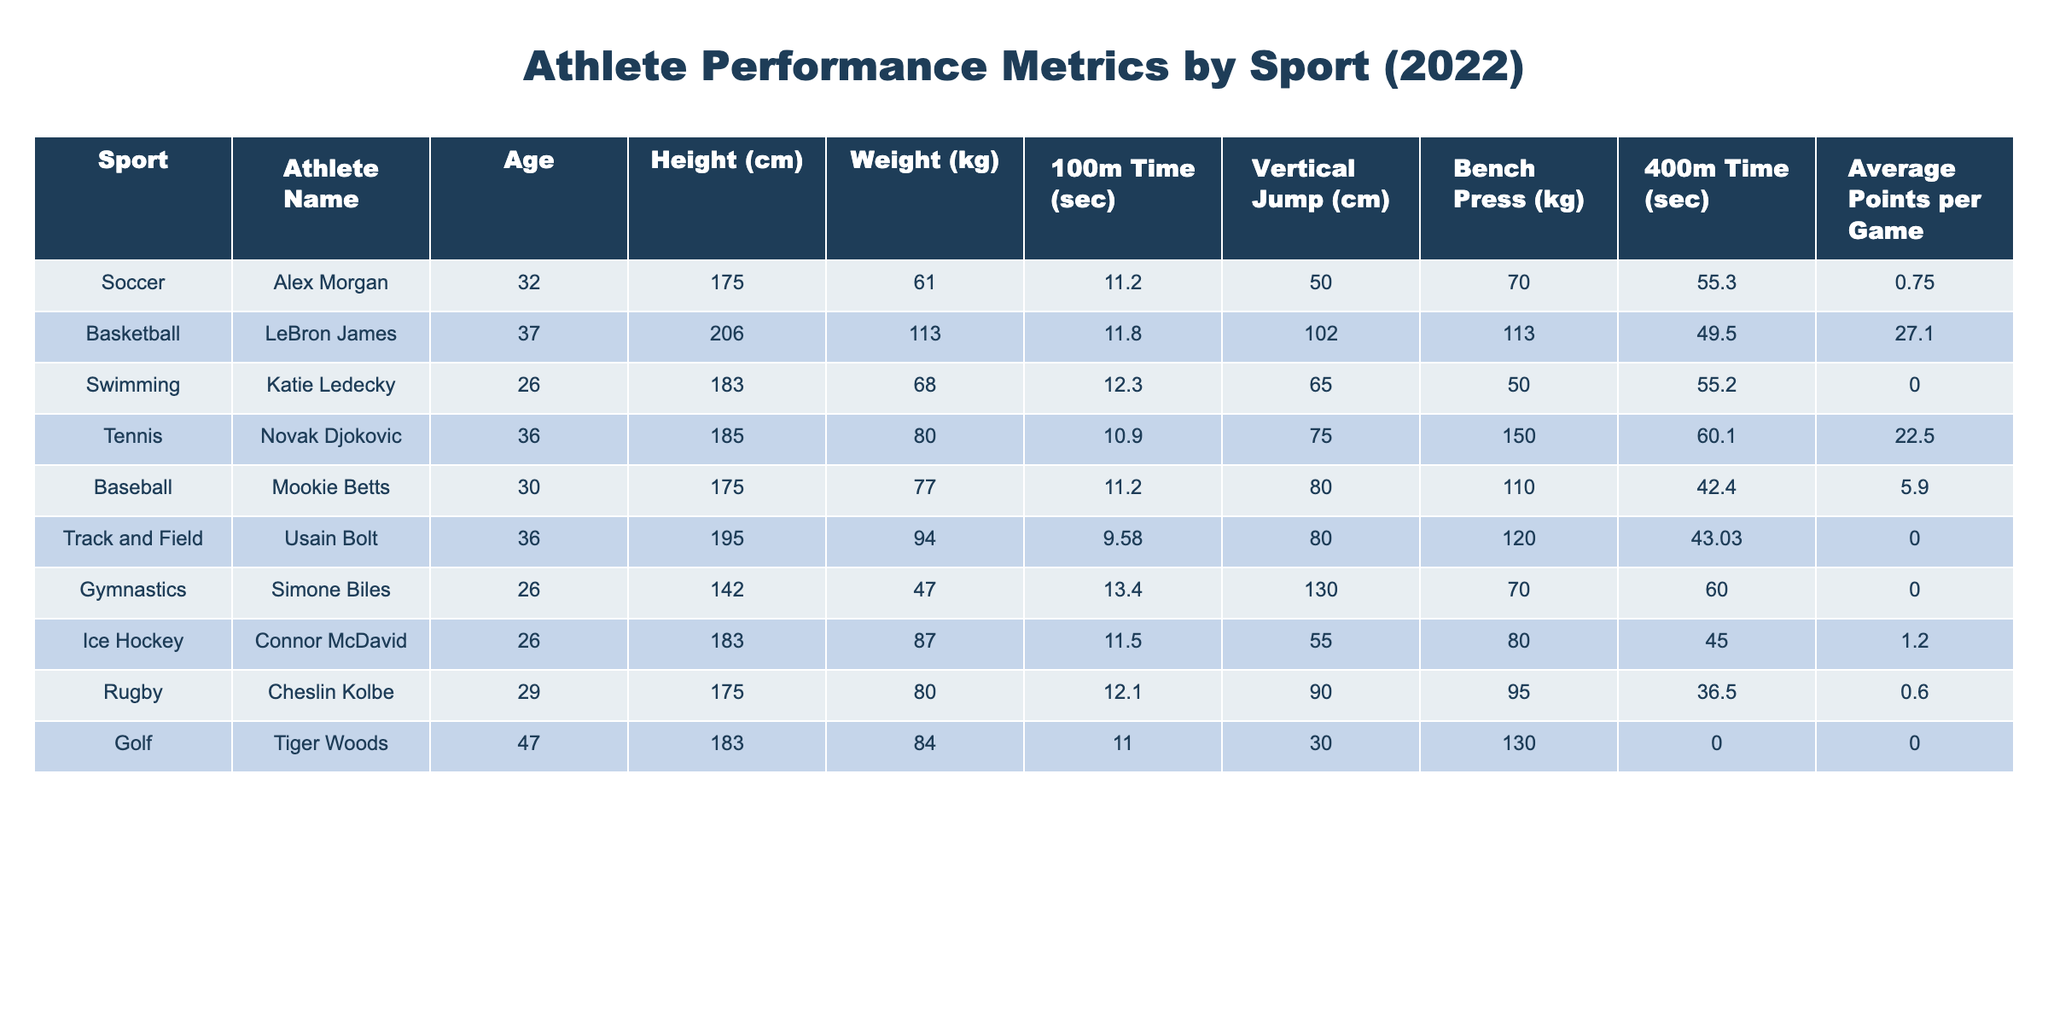What is the fastest 100m time recorded in the table? The fastest 100m time can be found by comparing the values in the "100m Time (sec)" column. The times listed are 11.2, 11.8, 12.3, 10.9, 11.2, 9.58, 13.4, 11.5, 12.1, and 11.0 seconds. The lowest value is 9.58 seconds from Usain Bolt.
Answer: 9.58 seconds Which athlete has the highest vertical jump? The vertical jumps are listed in the "Vertical Jump (cm)" column: 50, 102, 65, 75, 80, 80, 130, 55, 90, and 30 cm. The maximum value among these is 130 cm, achieved by Simone Biles.
Answer: Simone Biles What is the average weight of the athletes in the table? To find the average weight, sum the weights (61 + 113 + 68 + 80 + 77 + 94 + 47 + 87 + 80 + 84 = 585 kg) and divide by the number of athletes (10). Thus, average weight = 585 / 10 = 58.5 kg.
Answer: 58.5 kg Is there any athlete who scored an average of 0 points per game? By examining the "Average Points per Game" column, the values are 0.75, 27.1, 0, 22.5, 5.9, 0, 0, 1.2, 0.6, and 0. The presence of zeros indicates that multiple athletes scored 0 points per game. Yes, there are athletes with 0 points.
Answer: Yes What is the difference in 400m time between the fastest and the slowest athletes? The "400m Time (sec)" values are 55.3, 49.5, 55.2, 60.1, 42.4, 43.03, 60.0, 45.0, 36.5, and 0 seconds. The fastest time is 36.5 seconds (Cheslin Kolbe) and the slowest is 60.1 seconds (Novak Djokovic). The difference is 60.1 - 36.5 = 23.6 seconds.
Answer: 23.6 seconds Which sport has the youngest athlete? The ages listed are 32, 37, 26, 36, 30, 36, 26, 26, 29, and 47 years. The youngest is 26 years by Katie Ledecky, Simone Biles, and Connor McDavid. The sport associated with the youngest athletes are Swimming, Gymnastics, and Ice Hockey.
Answer: Swimming, Gymnastics, Ice Hockey 